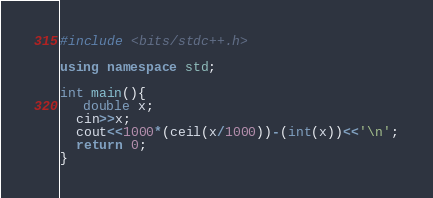Convert code to text. <code><loc_0><loc_0><loc_500><loc_500><_C++_>#include <bits/stdc++.h>

using namespace std;

int main(){
   double x;
  cin>>x;
  cout<<1000*(ceil(x/1000))-(int(x))<<'\n';
  return 0;
}</code> 